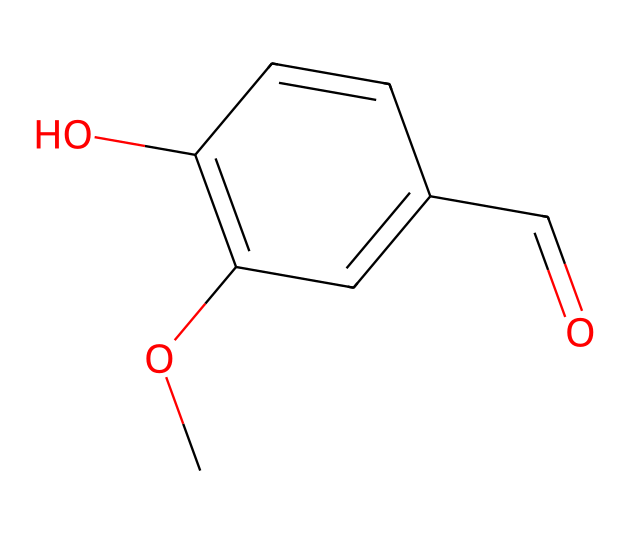What is the molecular formula of the compound represented by this SMILES? By analyzing the SMILES representation, we can count the number of carbon (C), hydrogen (H), and oxygen (O) atoms present in the structure. In the given SMILES, there are 9 carbon atoms, 10 hydrogen atoms, and 3 oxygen atoms, leading to the molecular formula C9H10O3.
Answer: C9H10O3 How many rings are present in the cage structure of this compound? The SMILES notation indicates a cyclical structure through the 'C1' notation, which signifies the start and end of a ring. In this case, there is one ring present in the structure.
Answer: 1 What functional groups are present in the vanilla compound? By examining the structure in the SMILES, we can identify functional groups such as the hydroxyl group (-OH) and the aldehyde group (-CHO), which influence the flavor profile of vanilla.
Answer: hydroxyl and aldehyde Does this compound contain any double bonds? The SMILES representation includes multiple connections signifying double bonds between carbon atoms, specifically shown by the '=' signs present in the structure. Hence, there are double bonds present.
Answer: yes Why is the structure considered cage-like? The term "cage-like" describes the molecular structure that resembles a three-dimensional configuration, providing spatial arrangement in the structure. In this compound, the arrangement of carbon and attached groups creates a selectively confined space or 'cage.'
Answer: spatial arrangement Which part of this molecule contributes to its sweet flavor? The structural components such as the aromatic ring and the specific arrangements of functional groups contribute to the sweet flavor of vanilla, as perceived by our taste receptors.
Answer: aromatic ring and functional groups 